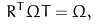Convert formula to latex. <formula><loc_0><loc_0><loc_500><loc_500>R ^ { T } \Omega T = \Omega ,</formula> 